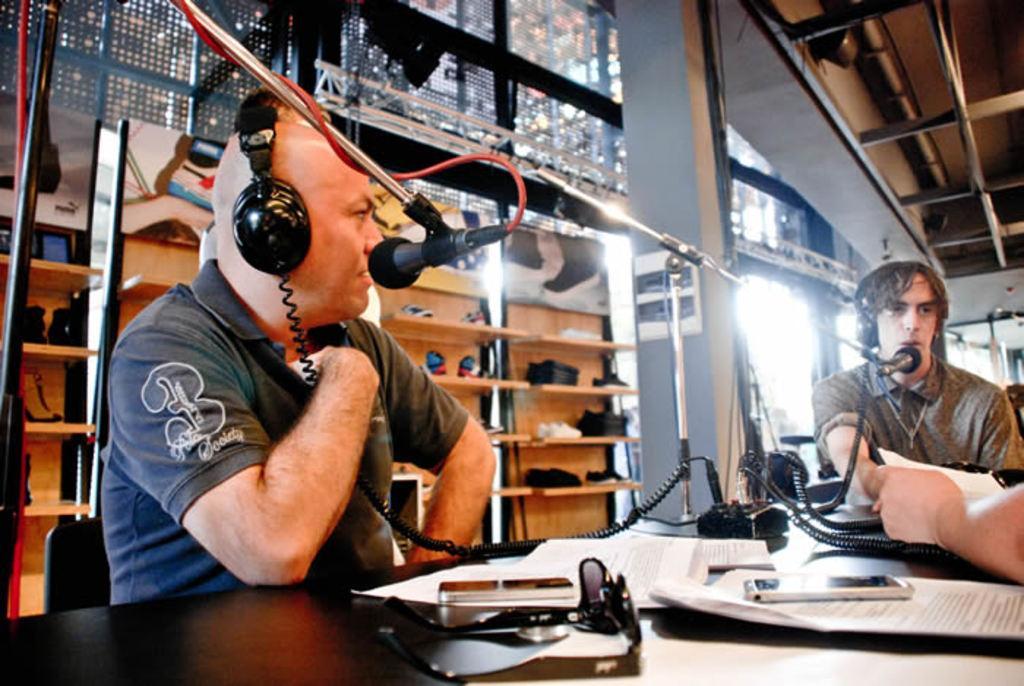In one or two sentences, can you explain what this image depicts? In this picture I can see two persons sitting on the chairs, there is another person holding papers, there are papers, mobiles, spectacles, miles with the miles stands and some other objects on the table, and in the background there are pairs of shoes on and in the racks, and there are iron rods. 